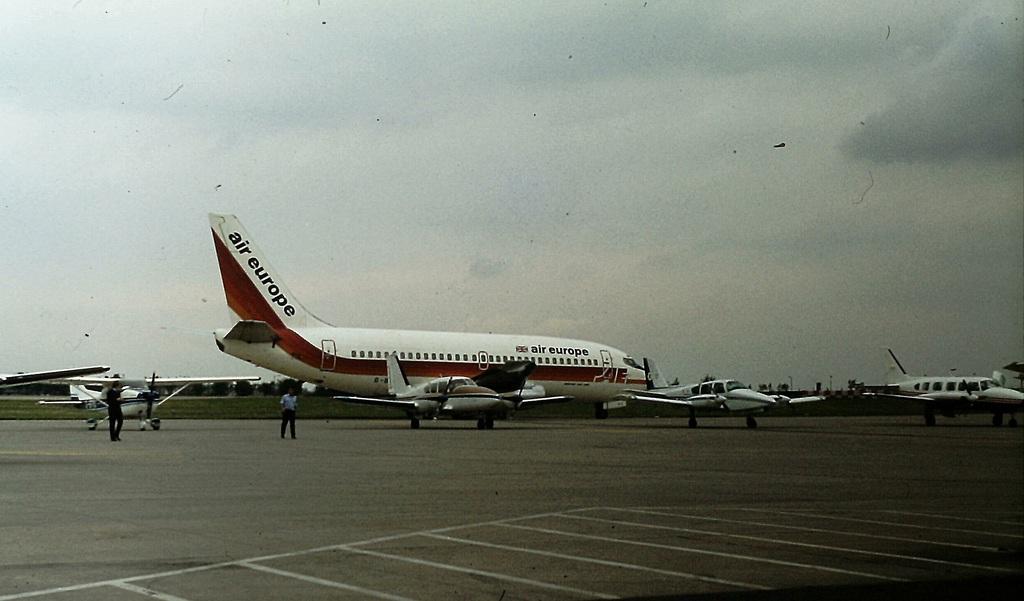Which airline is this jet plane?
Ensure brevity in your answer.  Air europe. What country is on the plane?
Your response must be concise. Unanswerable. 